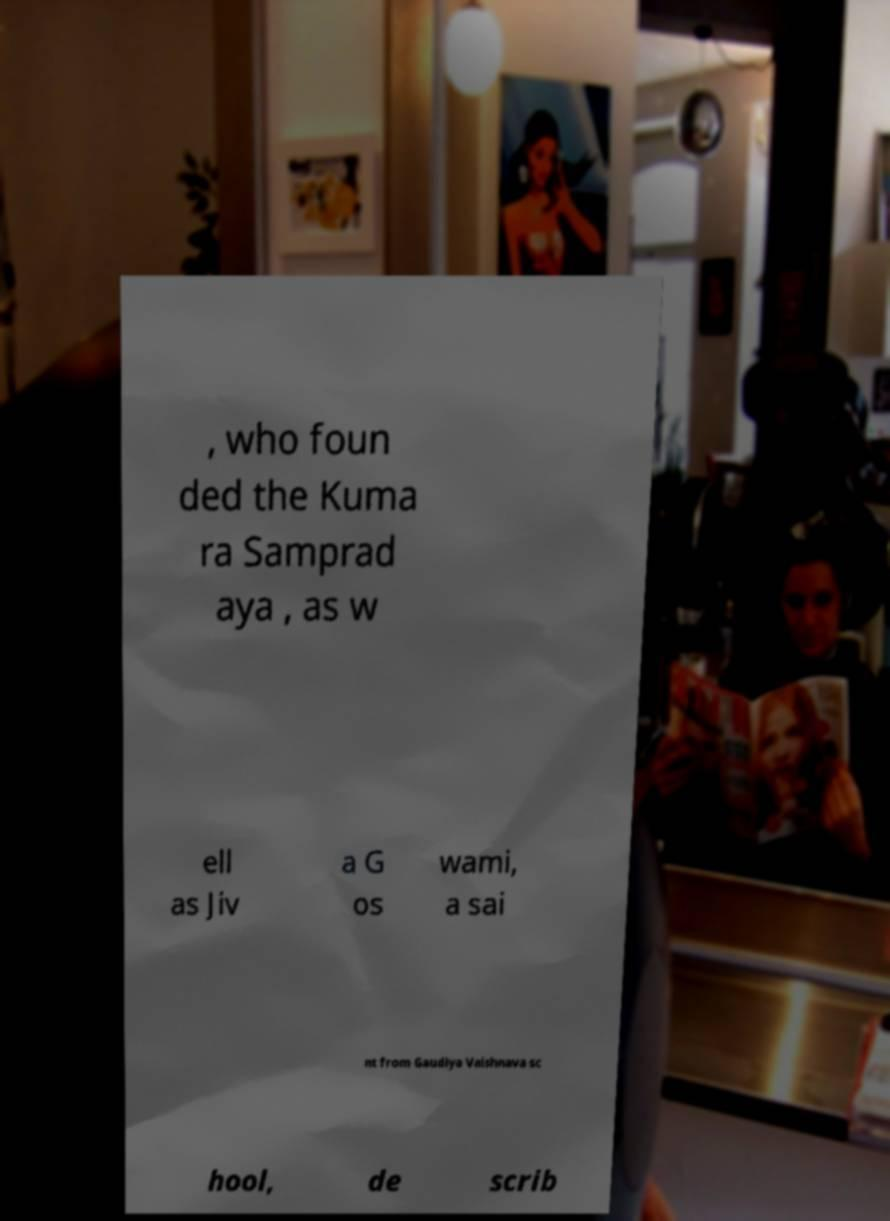Please identify and transcribe the text found in this image. , who foun ded the Kuma ra Samprad aya , as w ell as Jiv a G os wami, a sai nt from Gaudiya Vaishnava sc hool, de scrib 